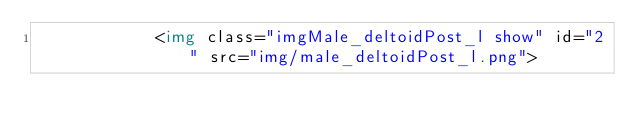Convert code to text. <code><loc_0><loc_0><loc_500><loc_500><_HTML_>            <img class="imgMale_deltoidPost_l show" id="2" src="img/male_deltoidPost_l.png"></code> 